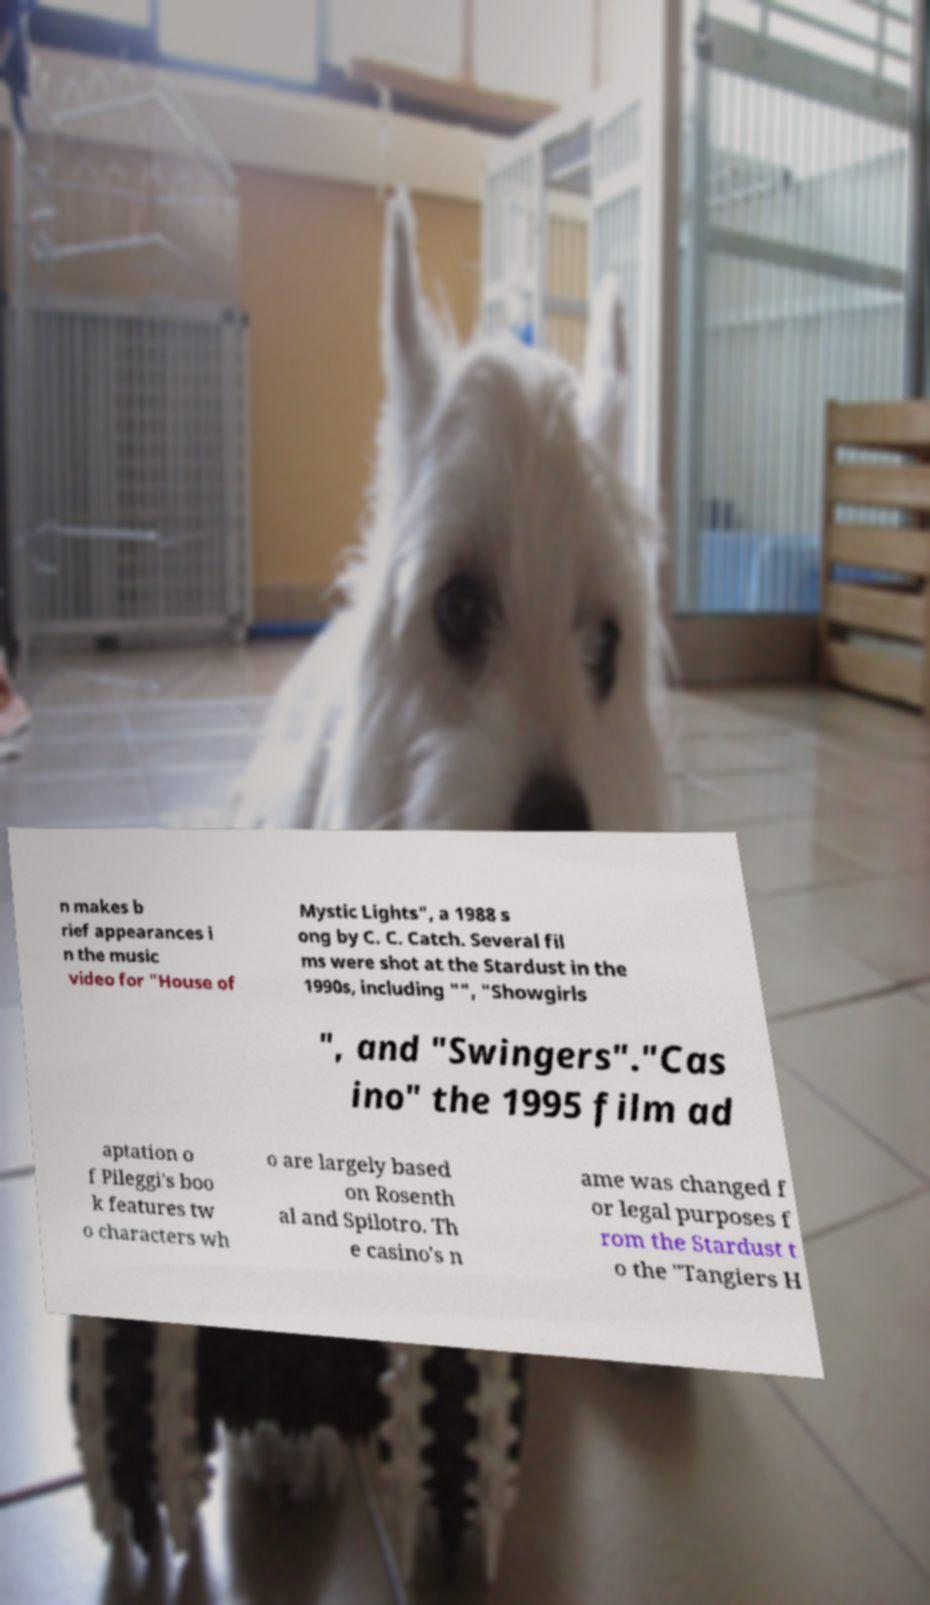For documentation purposes, I need the text within this image transcribed. Could you provide that? n makes b rief appearances i n the music video for "House of Mystic Lights", a 1988 s ong by C. C. Catch. Several fil ms were shot at the Stardust in the 1990s, including "", "Showgirls ", and "Swingers"."Cas ino" the 1995 film ad aptation o f Pileggi's boo k features tw o characters wh o are largely based on Rosenth al and Spilotro. Th e casino's n ame was changed f or legal purposes f rom the Stardust t o the "Tangiers H 